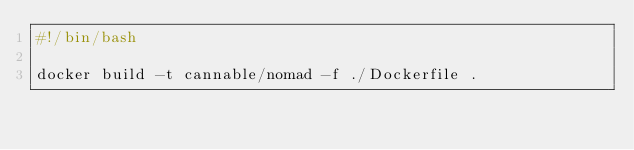Convert code to text. <code><loc_0><loc_0><loc_500><loc_500><_Bash_>#!/bin/bash

docker build -t cannable/nomad -f ./Dockerfile .
</code> 